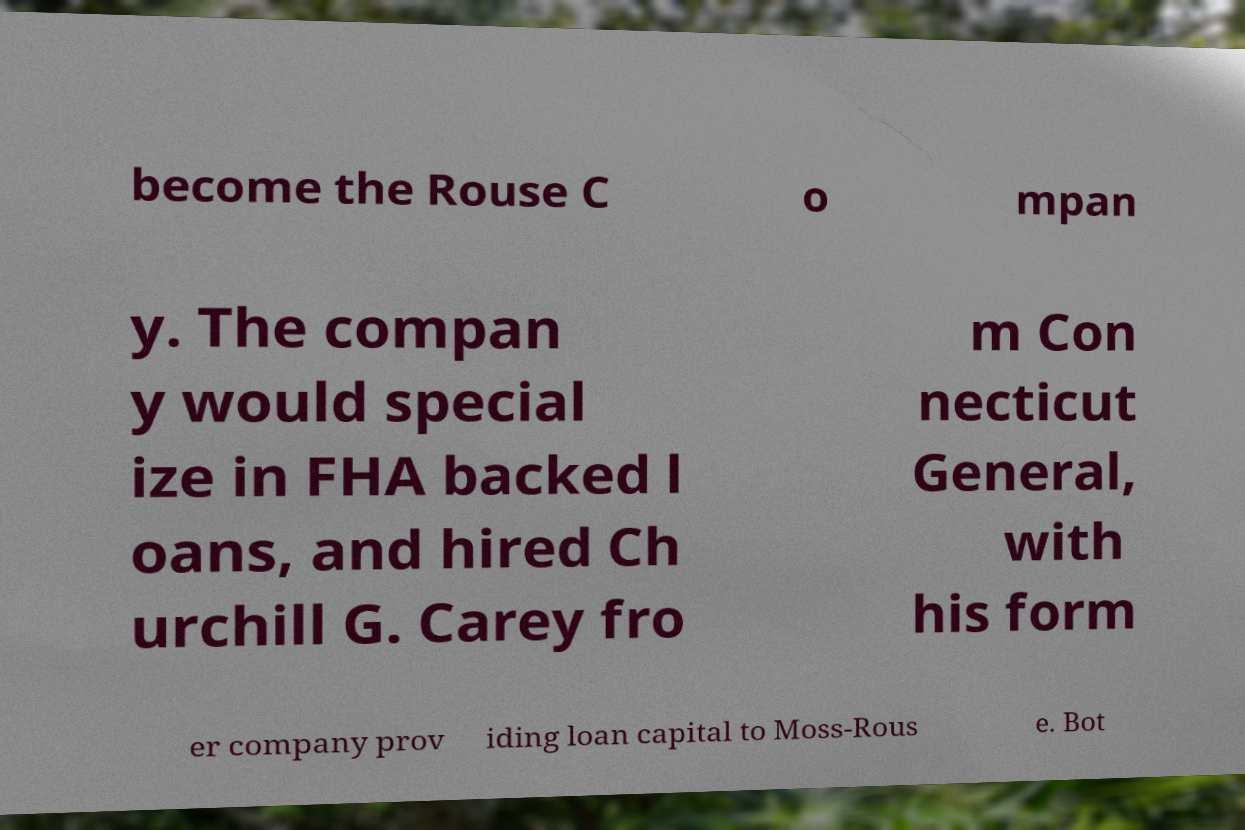I need the written content from this picture converted into text. Can you do that? become the Rouse C o mpan y. The compan y would special ize in FHA backed l oans, and hired Ch urchill G. Carey fro m Con necticut General, with his form er company prov iding loan capital to Moss-Rous e. Bot 